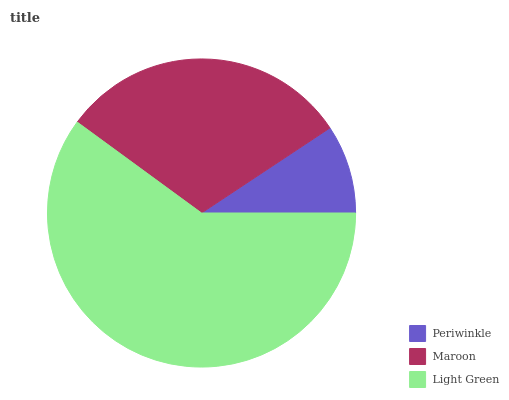Is Periwinkle the minimum?
Answer yes or no. Yes. Is Light Green the maximum?
Answer yes or no. Yes. Is Maroon the minimum?
Answer yes or no. No. Is Maroon the maximum?
Answer yes or no. No. Is Maroon greater than Periwinkle?
Answer yes or no. Yes. Is Periwinkle less than Maroon?
Answer yes or no. Yes. Is Periwinkle greater than Maroon?
Answer yes or no. No. Is Maroon less than Periwinkle?
Answer yes or no. No. Is Maroon the high median?
Answer yes or no. Yes. Is Maroon the low median?
Answer yes or no. Yes. Is Light Green the high median?
Answer yes or no. No. Is Light Green the low median?
Answer yes or no. No. 